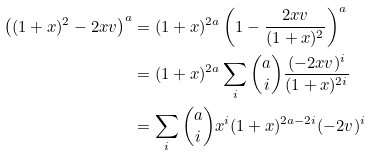Convert formula to latex. <formula><loc_0><loc_0><loc_500><loc_500>\left ( ( 1 + x ) ^ { 2 } - 2 x v \right ) ^ { a } & = ( 1 + x ) ^ { 2 a } \left ( 1 - \frac { 2 x v } { ( 1 + x ) ^ { 2 } } \right ) ^ { a } \\ & = ( 1 + x ) ^ { 2 a } \sum _ { i } \binom { a } { i } \frac { ( - 2 x v ) ^ { i } } { ( 1 + x ) ^ { 2 i } } \\ & = \sum _ { i } \binom { a } { i } x ^ { i } ( 1 + x ) ^ { 2 a - 2 i } ( - 2 v ) ^ { i }</formula> 